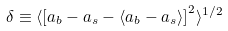Convert formula to latex. <formula><loc_0><loc_0><loc_500><loc_500>\delta \equiv \langle \left [ a _ { b } - a _ { s } - \langle a _ { b } - a _ { s } \rangle \right ] ^ { 2 } \rangle ^ { 1 / 2 }</formula> 